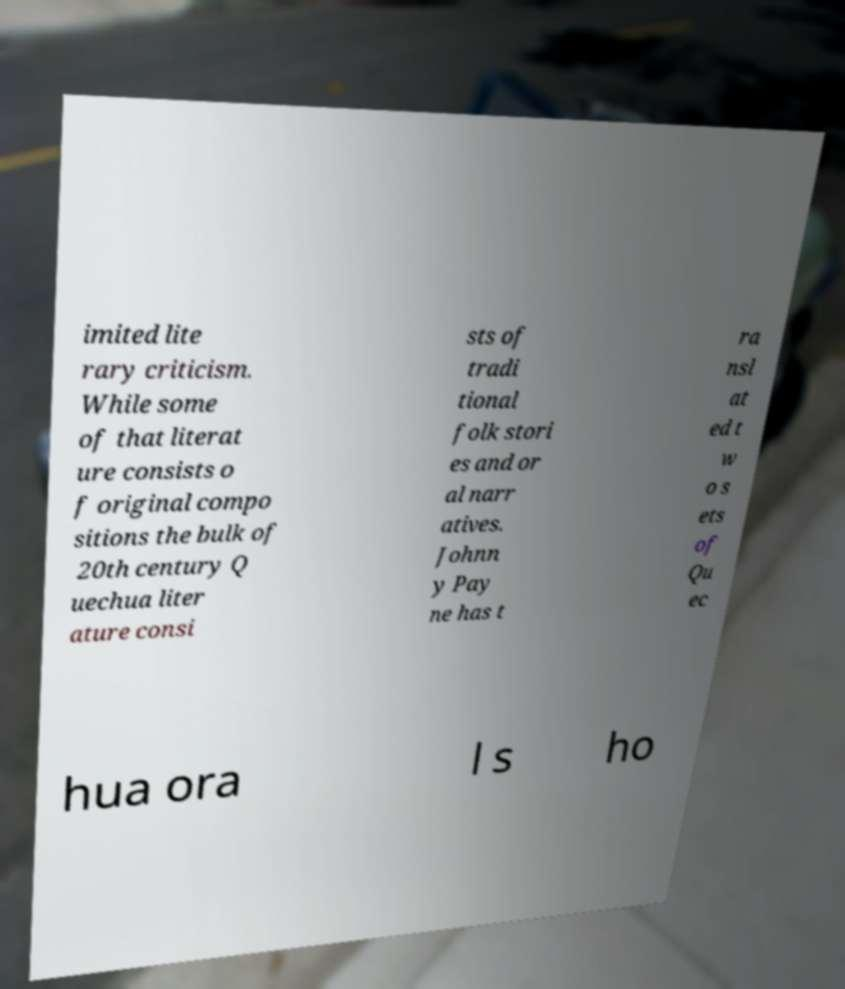I need the written content from this picture converted into text. Can you do that? imited lite rary criticism. While some of that literat ure consists o f original compo sitions the bulk of 20th century Q uechua liter ature consi sts of tradi tional folk stori es and or al narr atives. Johnn y Pay ne has t ra nsl at ed t w o s ets of Qu ec hua ora l s ho 